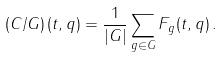<formula> <loc_0><loc_0><loc_500><loc_500>\left ( C / G \right ) ( t , q ) = \frac { 1 } { | G | } \sum _ { g \in G } F _ { g } ( t , q ) \, .</formula> 